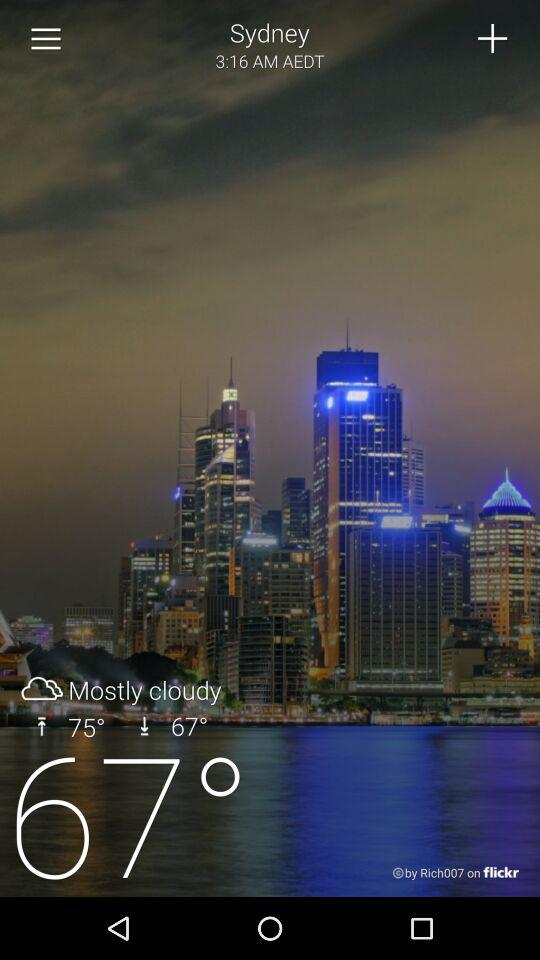What is the time in sydney? The time is 3:16 AM AEDT. 